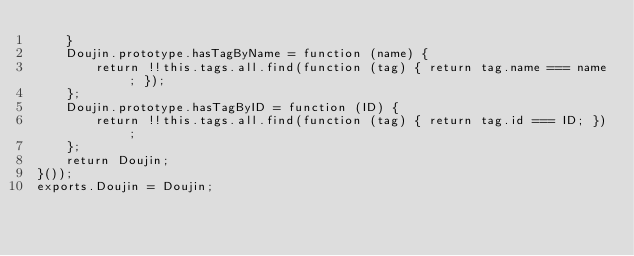Convert code to text. <code><loc_0><loc_0><loc_500><loc_500><_JavaScript_>    }
    Doujin.prototype.hasTagByName = function (name) {
        return !!this.tags.all.find(function (tag) { return tag.name === name; });
    };
    Doujin.prototype.hasTagByID = function (ID) {
        return !!this.tags.all.find(function (tag) { return tag.id === ID; });
    };
    return Doujin;
}());
exports.Doujin = Doujin;
</code> 